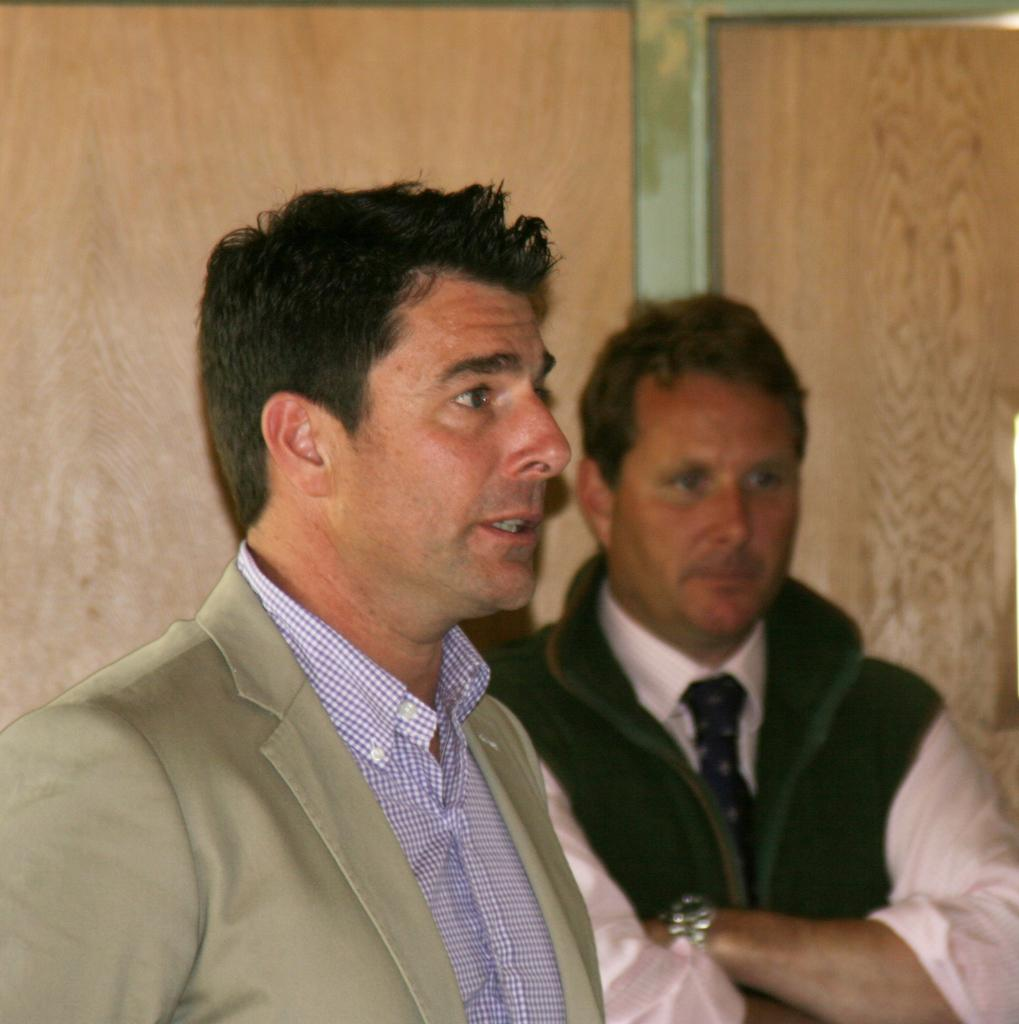How many people are present in the image? There are two people standing in the image. What can be seen in the background of the image? There is a wooden wall in the background of the image. What type of object is attached to the wooden wall? There is an iron object on the wooden wall. What type of nerve can be seen in the image? There is no nerve present in the image. Are there any planes visible in the image? There are no planes visible in the image. 